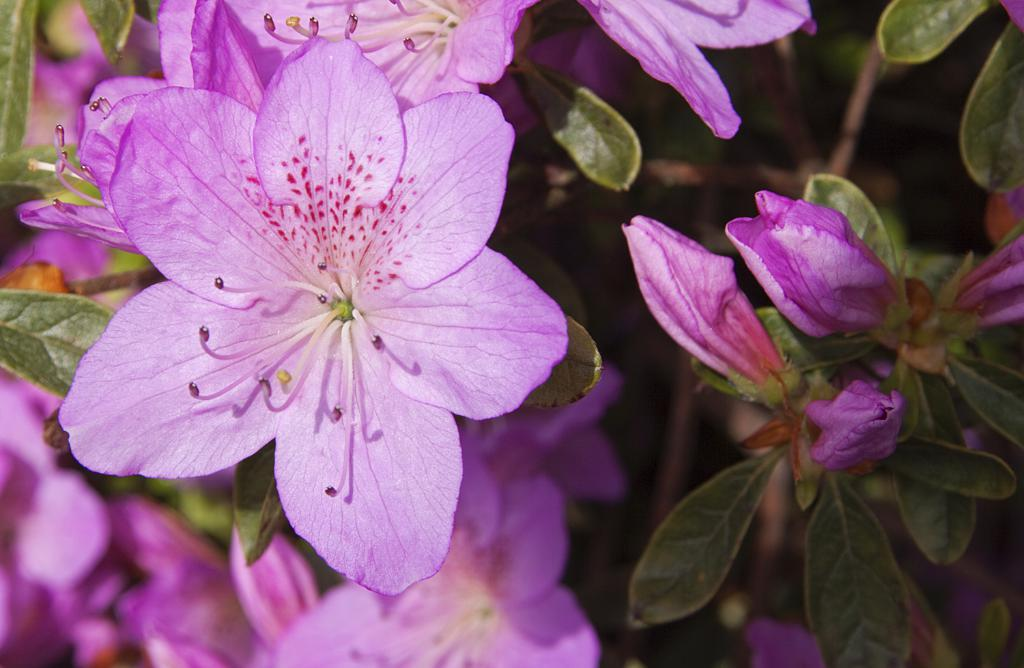What type of plants can be seen in the image? There are flowers in the image. What colors are the flowers? The flowers are pink and cream in color. What else can be seen in the image besides the flowers? There are leaves in the image. What color are the leaves? The leaves are green in color. How many rabbits are hiding among the flowers in the image? There are no rabbits present in the image; it only features flowers and leaves. 